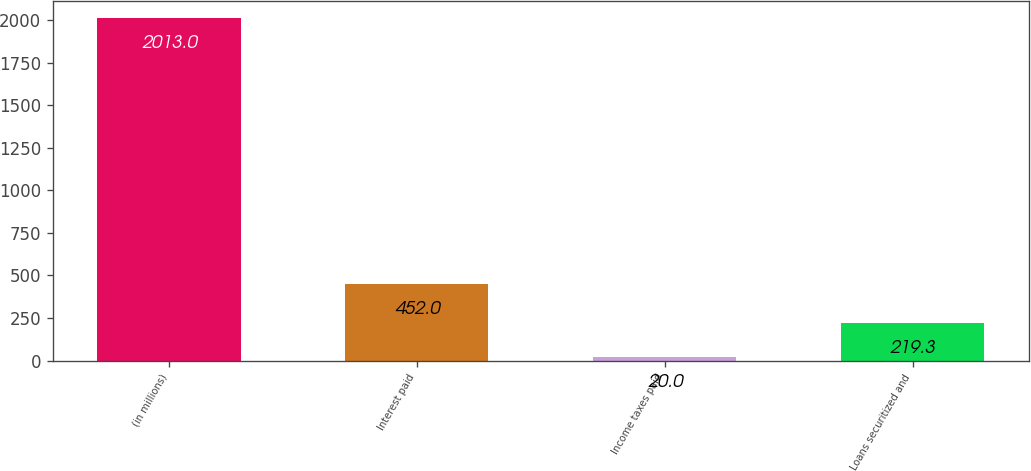<chart> <loc_0><loc_0><loc_500><loc_500><bar_chart><fcel>(in millions)<fcel>Interest paid<fcel>Income taxes paid<fcel>Loans securitized and<nl><fcel>2013<fcel>452<fcel>20<fcel>219.3<nl></chart> 